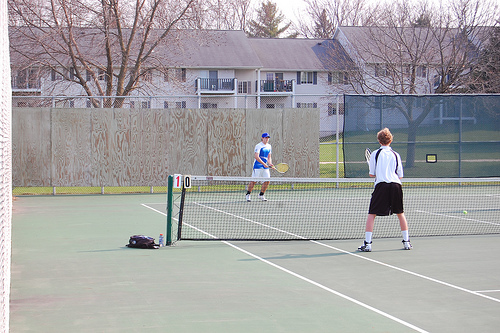What equipment do you see in the image related to the sport? I can see tennis rackets being held by the players and a tennis ball. There's also a bag lying on the court, likely containing spare balls or other personal items. Can you tell me more about the environment in which they're playing? Certainly! They're playing on an outdoor tennis court with a green surface. The court is fenced, and there's a mix of trees and buildings in the background, indicating the court is likely situated in a community area. 